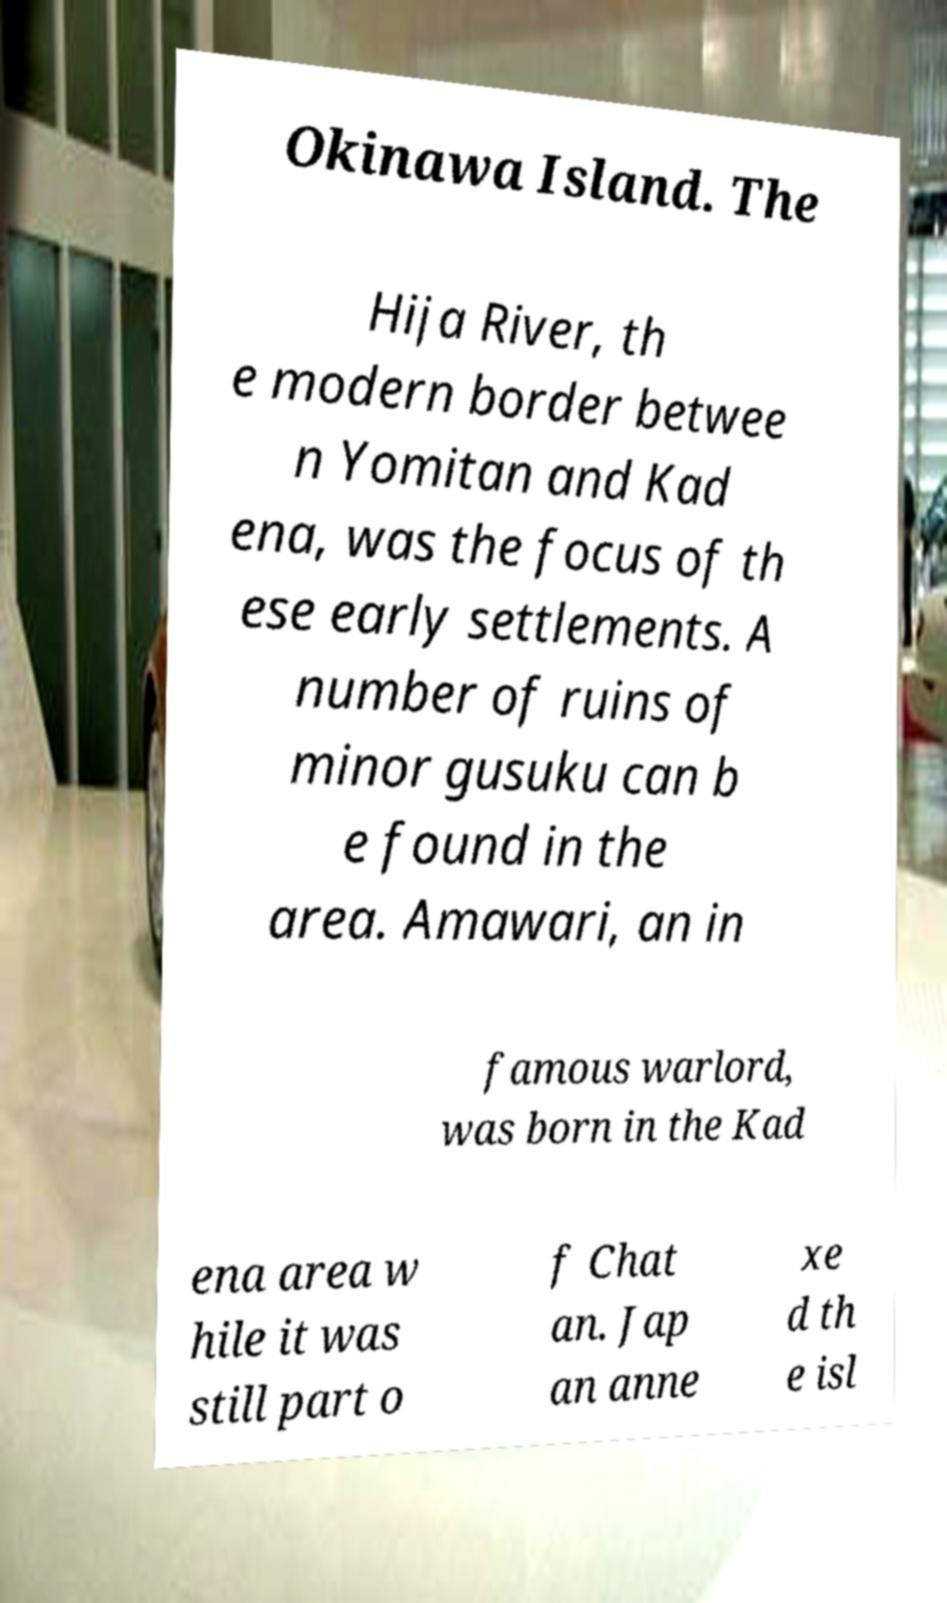What messages or text are displayed in this image? I need them in a readable, typed format. Okinawa Island. The Hija River, th e modern border betwee n Yomitan and Kad ena, was the focus of th ese early settlements. A number of ruins of minor gusuku can b e found in the area. Amawari, an in famous warlord, was born in the Kad ena area w hile it was still part o f Chat an. Jap an anne xe d th e isl 